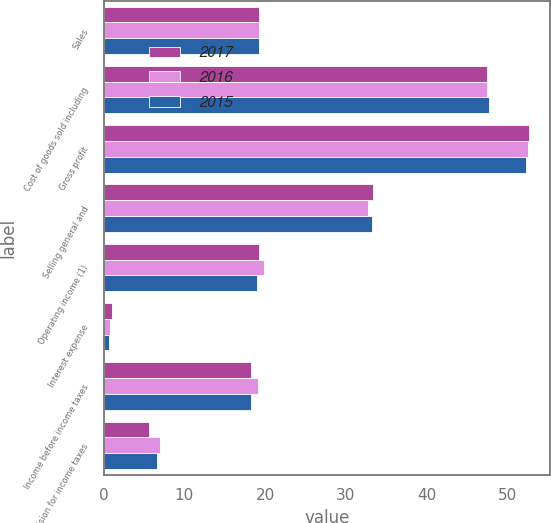Convert chart. <chart><loc_0><loc_0><loc_500><loc_500><stacked_bar_chart><ecel><fcel>Sales<fcel>Cost of goods sold including<fcel>Gross profit<fcel>Selling general and<fcel>Operating income (1)<fcel>Interest expense<fcel>Income before income taxes<fcel>Provision for income taxes<nl><fcel>2017<fcel>19.2<fcel>47.4<fcel>52.6<fcel>33.4<fcel>19.2<fcel>1<fcel>18.2<fcel>5.6<nl><fcel>2016<fcel>19.2<fcel>47.5<fcel>52.5<fcel>32.7<fcel>19.8<fcel>0.8<fcel>19.1<fcel>7<nl><fcel>2015<fcel>19.2<fcel>47.7<fcel>52.3<fcel>33.2<fcel>19<fcel>0.7<fcel>18.3<fcel>6.6<nl></chart> 